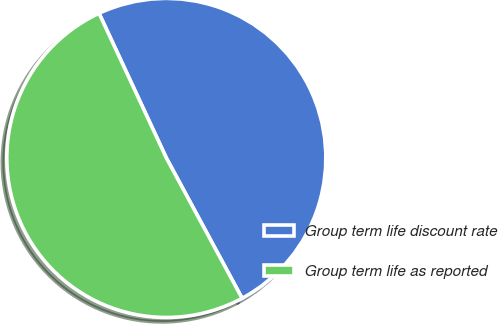<chart> <loc_0><loc_0><loc_500><loc_500><pie_chart><fcel>Group term life discount rate<fcel>Group term life as reported<nl><fcel>49.05%<fcel>50.95%<nl></chart> 